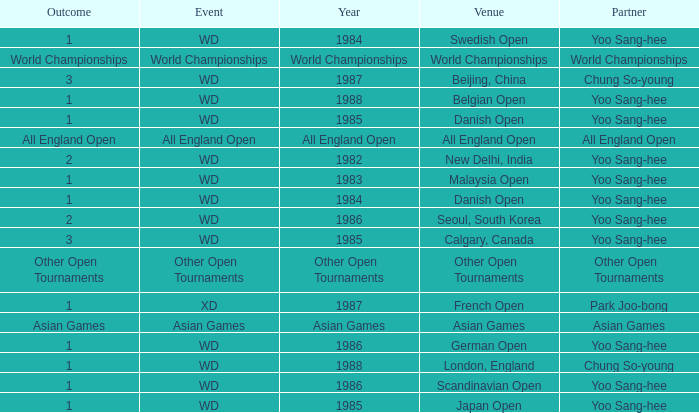What was the Outcome in 1983 of the WD Event? 1.0. Can you give me this table as a dict? {'header': ['Outcome', 'Event', 'Year', 'Venue', 'Partner'], 'rows': [['1', 'WD', '1984', 'Swedish Open', 'Yoo Sang-hee'], ['World Championships', 'World Championships', 'World Championships', 'World Championships', 'World Championships'], ['3', 'WD', '1987', 'Beijing, China', 'Chung So-young'], ['1', 'WD', '1988', 'Belgian Open', 'Yoo Sang-hee'], ['1', 'WD', '1985', 'Danish Open', 'Yoo Sang-hee'], ['All England Open', 'All England Open', 'All England Open', 'All England Open', 'All England Open'], ['2', 'WD', '1982', 'New Delhi, India', 'Yoo Sang-hee'], ['1', 'WD', '1983', 'Malaysia Open', 'Yoo Sang-hee'], ['1', 'WD', '1984', 'Danish Open', 'Yoo Sang-hee'], ['2', 'WD', '1986', 'Seoul, South Korea', 'Yoo Sang-hee'], ['3', 'WD', '1985', 'Calgary, Canada', 'Yoo Sang-hee'], ['Other Open Tournaments', 'Other Open Tournaments', 'Other Open Tournaments', 'Other Open Tournaments', 'Other Open Tournaments'], ['1', 'XD', '1987', 'French Open', 'Park Joo-bong'], ['Asian Games', 'Asian Games', 'Asian Games', 'Asian Games', 'Asian Games'], ['1', 'WD', '1986', 'German Open', 'Yoo Sang-hee'], ['1', 'WD', '1988', 'London, England', 'Chung So-young'], ['1', 'WD', '1986', 'Scandinavian Open', 'Yoo Sang-hee'], ['1', 'WD', '1985', 'Japan Open', 'Yoo Sang-hee']]} 